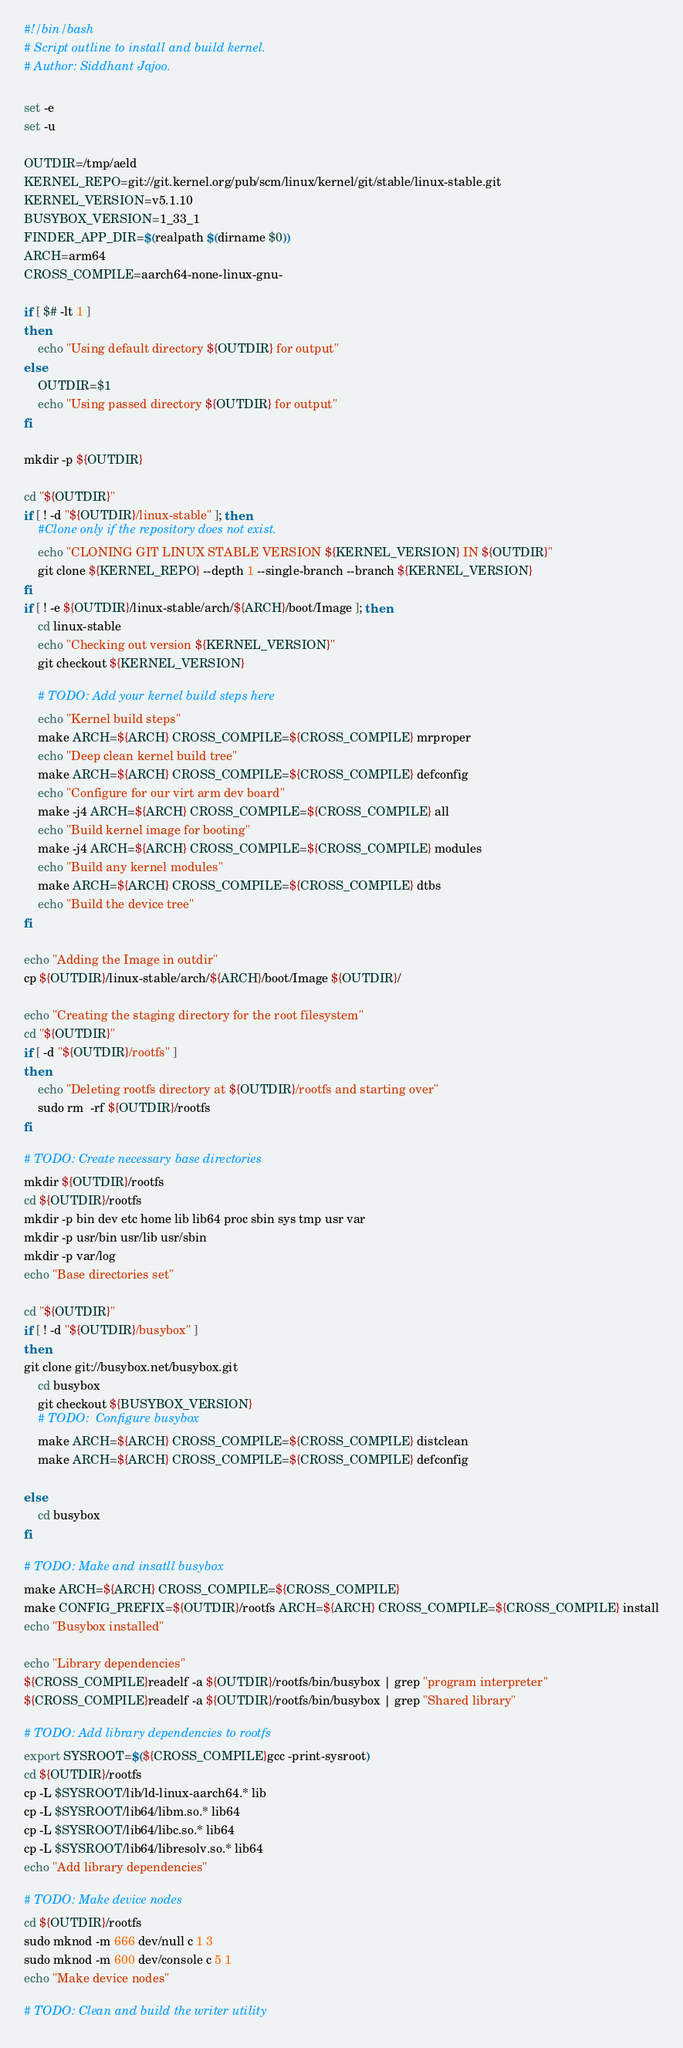Convert code to text. <code><loc_0><loc_0><loc_500><loc_500><_Bash_>#!/bin/bash
# Script outline to install and build kernel.
# Author: Siddhant Jajoo.

set -e
set -u

OUTDIR=/tmp/aeld
KERNEL_REPO=git://git.kernel.org/pub/scm/linux/kernel/git/stable/linux-stable.git
KERNEL_VERSION=v5.1.10
BUSYBOX_VERSION=1_33_1
FINDER_APP_DIR=$(realpath $(dirname $0))
ARCH=arm64
CROSS_COMPILE=aarch64-none-linux-gnu-

if [ $# -lt 1 ]
then
	echo "Using default directory ${OUTDIR} for output"
else
	OUTDIR=$1
	echo "Using passed directory ${OUTDIR} for output"
fi

mkdir -p ${OUTDIR}

cd "${OUTDIR}"
if [ ! -d "${OUTDIR}/linux-stable" ]; then
    #Clone only if the repository does not exist.
	echo "CLONING GIT LINUX STABLE VERSION ${KERNEL_VERSION} IN ${OUTDIR}"
	git clone ${KERNEL_REPO} --depth 1 --single-branch --branch ${KERNEL_VERSION}
fi
if [ ! -e ${OUTDIR}/linux-stable/arch/${ARCH}/boot/Image ]; then
    cd linux-stable
    echo "Checking out version ${KERNEL_VERSION}"
    git checkout ${KERNEL_VERSION}

    # TODO: Add your kernel build steps here
    echo "Kernel build steps"
    make ARCH=${ARCH} CROSS_COMPILE=${CROSS_COMPILE} mrproper
    echo "Deep clean kernel build tree"
    make ARCH=${ARCH} CROSS_COMPILE=${CROSS_COMPILE} defconfig
    echo "Configure for our virt arm dev board"
    make -j4 ARCH=${ARCH} CROSS_COMPILE=${CROSS_COMPILE} all
    echo "Build kernel image for booting"
    make -j4 ARCH=${ARCH} CROSS_COMPILE=${CROSS_COMPILE} modules
    echo "Build any kernel modules"
    make ARCH=${ARCH} CROSS_COMPILE=${CROSS_COMPILE} dtbs
    echo "Build the device tree"
fi 

echo "Adding the Image in outdir"
cp ${OUTDIR}/linux-stable/arch/${ARCH}/boot/Image ${OUTDIR}/

echo "Creating the staging directory for the root filesystem"
cd "${OUTDIR}"
if [ -d "${OUTDIR}/rootfs" ]
then
	echo "Deleting rootfs directory at ${OUTDIR}/rootfs and starting over"
    sudo rm  -rf ${OUTDIR}/rootfs
fi

# TODO: Create necessary base directories
mkdir ${OUTDIR}/rootfs
cd ${OUTDIR}/rootfs
mkdir -p bin dev etc home lib lib64 proc sbin sys tmp usr var
mkdir -p usr/bin usr/lib usr/sbin
mkdir -p var/log
echo "Base directories set"

cd "${OUTDIR}"
if [ ! -d "${OUTDIR}/busybox" ]
then
git clone git://busybox.net/busybox.git
    cd busybox
    git checkout ${BUSYBOX_VERSION}
    # TODO:  Configure busybox
    make ARCH=${ARCH} CROSS_COMPILE=${CROSS_COMPILE} distclean
    make ARCH=${ARCH} CROSS_COMPILE=${CROSS_COMPILE} defconfig

else
    cd busybox
fi

# TODO: Make and insatll busybox
make ARCH=${ARCH} CROSS_COMPILE=${CROSS_COMPILE}
make CONFIG_PREFIX=${OUTDIR}/rootfs ARCH=${ARCH} CROSS_COMPILE=${CROSS_COMPILE} install
echo "Busybox installed"

echo "Library dependencies"
${CROSS_COMPILE}readelf -a ${OUTDIR}/rootfs/bin/busybox | grep "program interpreter"
${CROSS_COMPILE}readelf -a ${OUTDIR}/rootfs/bin/busybox | grep "Shared library"

# TODO: Add library dependencies to rootfs
export SYSROOT=$(${CROSS_COMPILE}gcc -print-sysroot)
cd ${OUTDIR}/rootfs
cp -L $SYSROOT/lib/ld-linux-aarch64.* lib
cp -L $SYSROOT/lib64/libm.so.* lib64
cp -L $SYSROOT/lib64/libc.so.* lib64
cp -L $SYSROOT/lib64/libresolv.so.* lib64
echo "Add library dependencies"

# TODO: Make device nodes
cd ${OUTDIR}/rootfs
sudo mknod -m 666 dev/null c 1 3
sudo mknod -m 600 dev/console c 5 1
echo "Make device nodes"

# TODO: Clean and build the writer utility</code> 